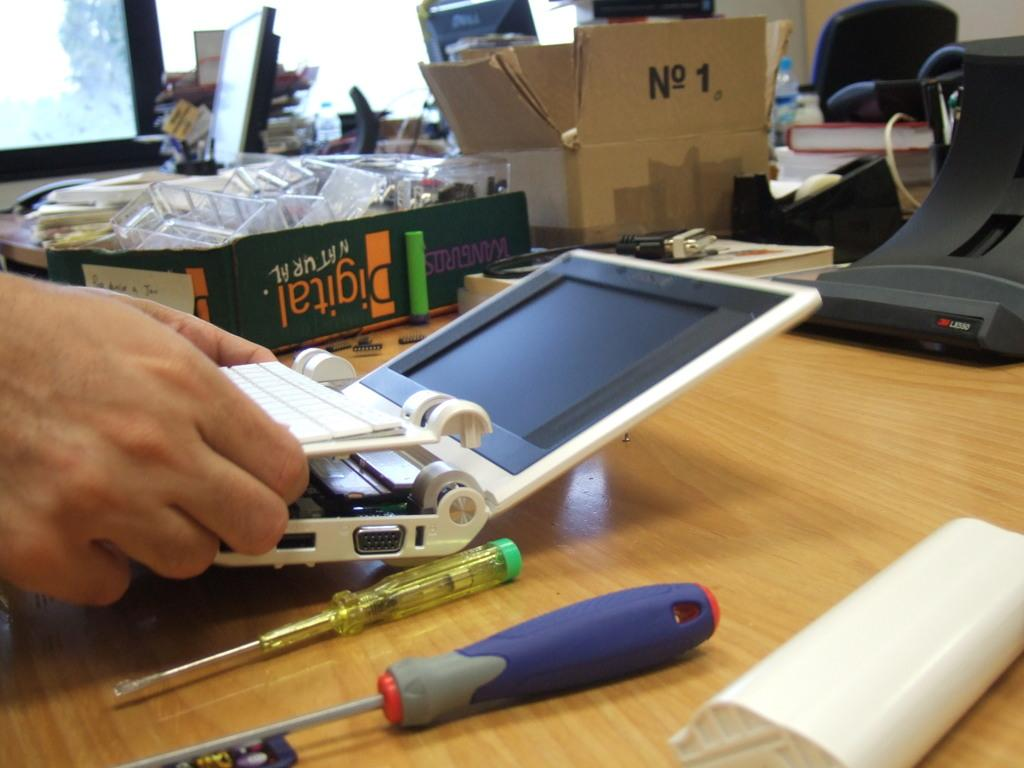Provide a one-sentence caption for the provided image. A tech repairman putting a broken netbook back together. 